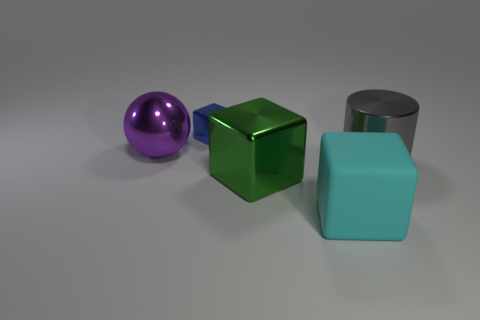Subtract 1 cubes. How many cubes are left? 2 Add 3 big cylinders. How many objects exist? 8 Subtract all cubes. How many objects are left? 2 Subtract all large red metal cubes. Subtract all large green blocks. How many objects are left? 4 Add 1 metallic blocks. How many metallic blocks are left? 3 Add 2 small brown metal objects. How many small brown metal objects exist? 2 Subtract 0 purple blocks. How many objects are left? 5 